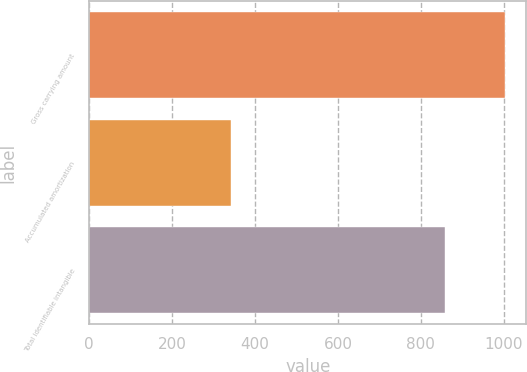Convert chart. <chart><loc_0><loc_0><loc_500><loc_500><bar_chart><fcel>Gross carrying amount<fcel>Accumulated amortization<fcel>Total identifiable intangible<nl><fcel>1003.8<fcel>342.3<fcel>858<nl></chart> 